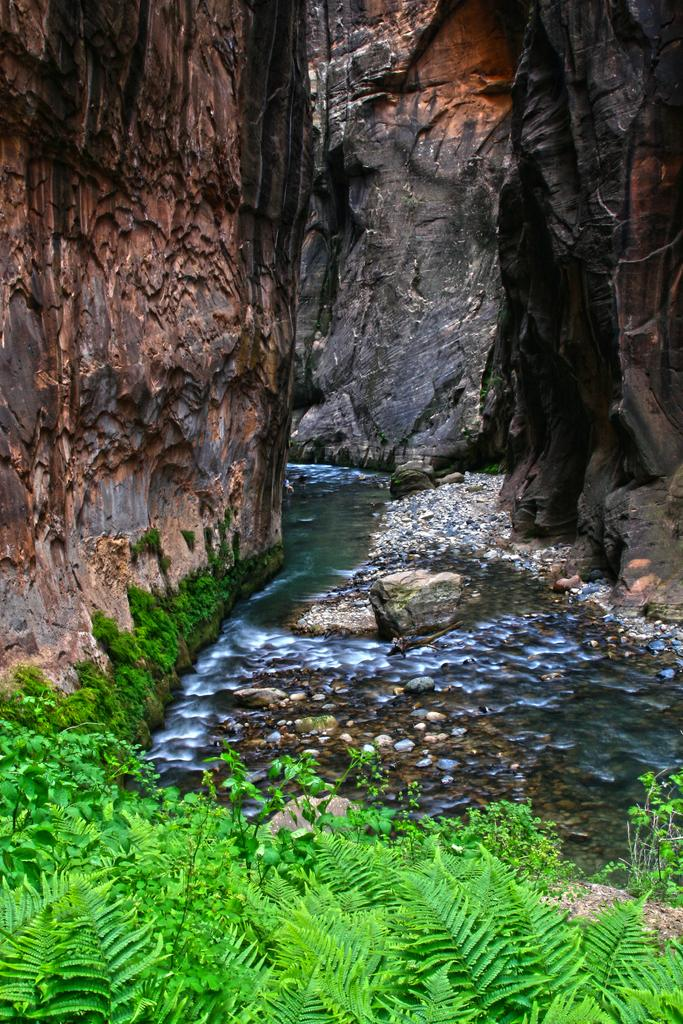What type of living organisms can be seen in the image? Plants are visible in the image. What is the bird in the image doing? A bird is flying in the air in the image. What can be seen in the background of the image? There is water visible in the image. What type of natural formation is present in the image? There are rocks in the image. What type of jam is being spread on the rocks in the image? There is no jam present in the image; it features plants, a flying bird, water, and rocks. 